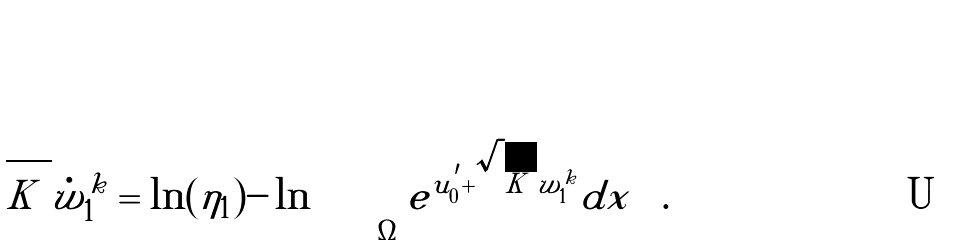Convert formula to latex. <formula><loc_0><loc_0><loc_500><loc_500>\sqrt { | K | } \dot { w } ^ { k } _ { 1 } = \ln ( \eta _ { 1 } ) - \ln \left ( \int _ { \Omega } { e ^ { u _ { 0 } ^ { ^ { \prime } } + \sqrt { | K | } \tilde { w } ^ { k } _ { 1 } } } d x \right ) .</formula> 